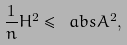<formula> <loc_0><loc_0><loc_500><loc_500>\frac { 1 } { n } H ^ { 2 } \leq \ a b s { A } ^ { 2 } ,</formula> 